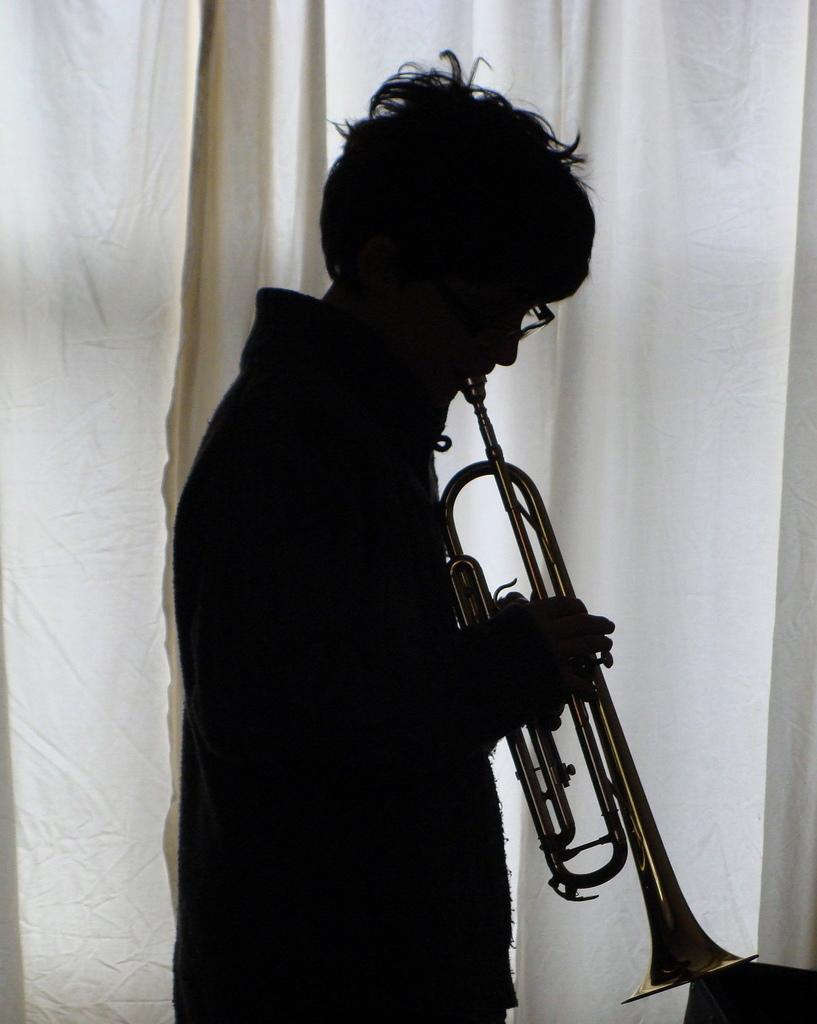What is the main subject of the image? There is a person in the image. What is the person doing in the image? The person is playing a musical instrument. What can be seen in the background of the image? There is a curtain in the background of the image. What type of butter is being used to play the musical instrument in the image? There is no butter present in the image, and it is not being used to play the musical instrument. 